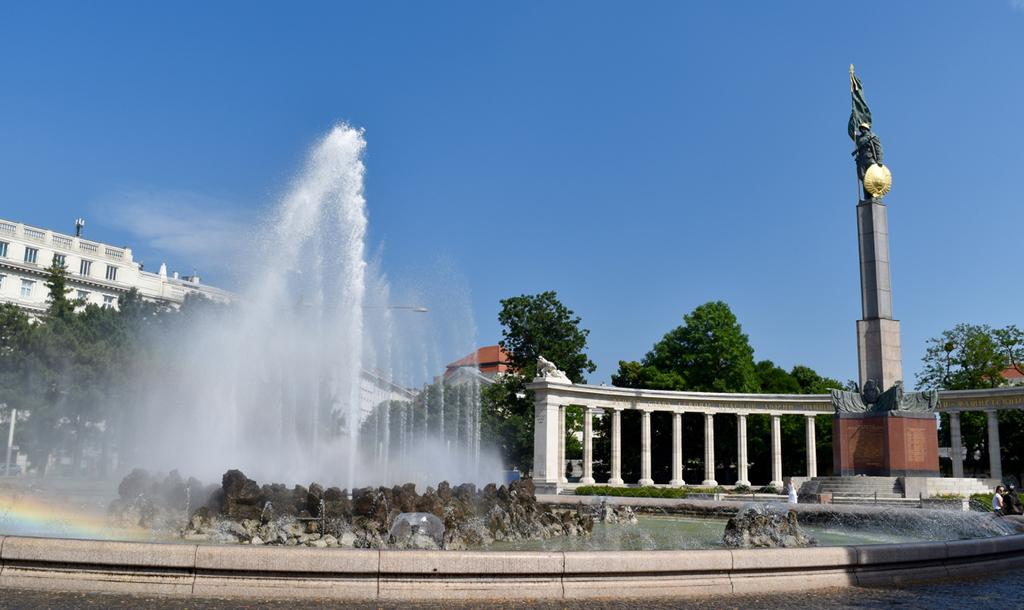What is the main feature in the image? There is a water fountain in the image. What else can be seen in the image besides the water fountain? There are buildings, pillars, a sculpture, trees, and the sky visible in the image. Can you describe the architectural elements in the image? There are buildings and pillars in the image. What type of vegetation is present in the image? There are trees in the image. What is visible in the background of the image? The sky is visible in the background of the image. What type of cushion is being used to support the space shuttle in the image? There is no space shuttle or cushion present in the image. 